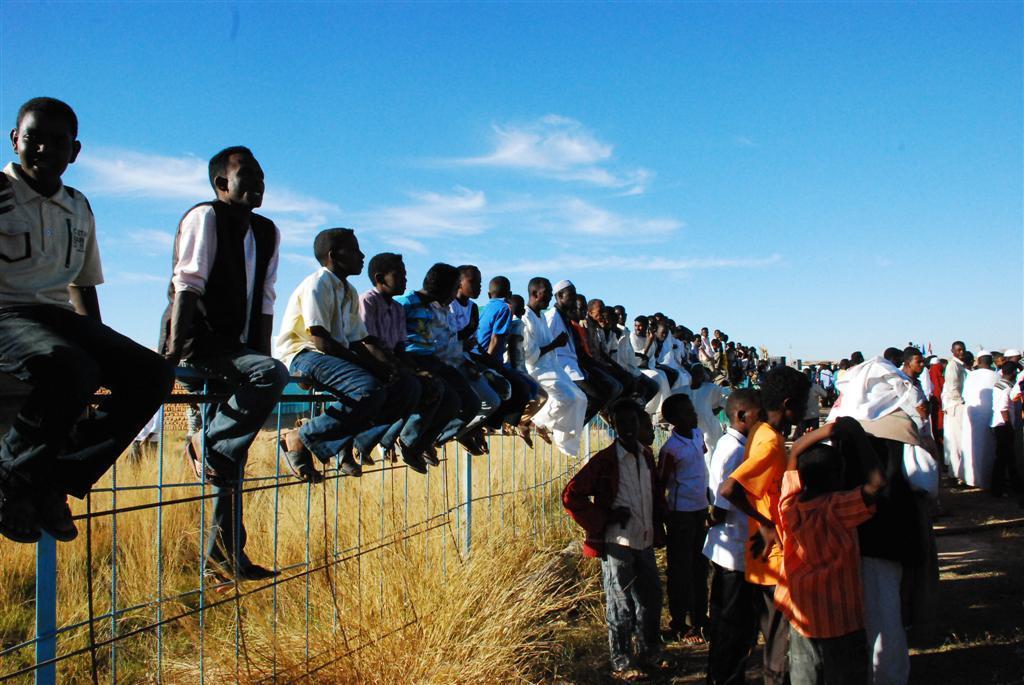Describe this image in one or two sentences. On the right side, we see people are standing on the road. Behind them, we see a fence. We see many people are sitting on the iron fence. Behind them, we see the grass. At the top, we see the sky, which is blue in color. 